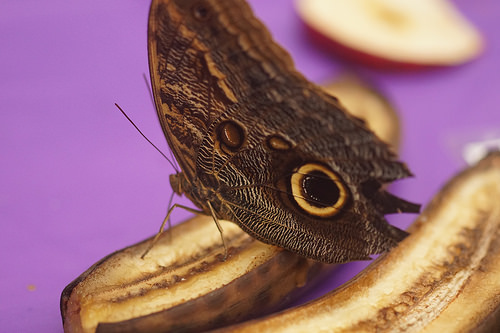<image>
Can you confirm if the butterfly is on the fruit? Yes. Looking at the image, I can see the butterfly is positioned on top of the fruit, with the fruit providing support. Where is the butterfly in relation to the banana? Is it on the banana? Yes. Looking at the image, I can see the butterfly is positioned on top of the banana, with the banana providing support. 